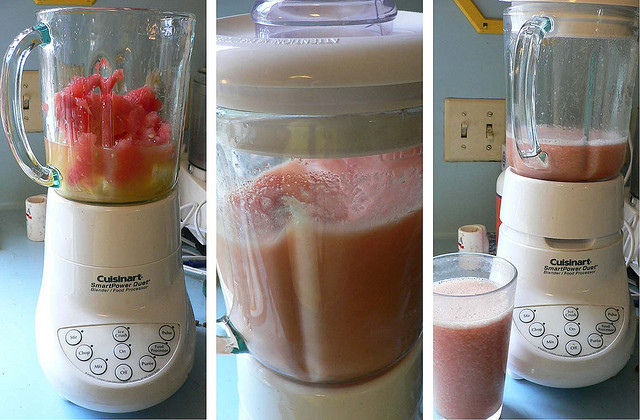Identify the text displayed in this image. Culslnard SmartPower culslnart 